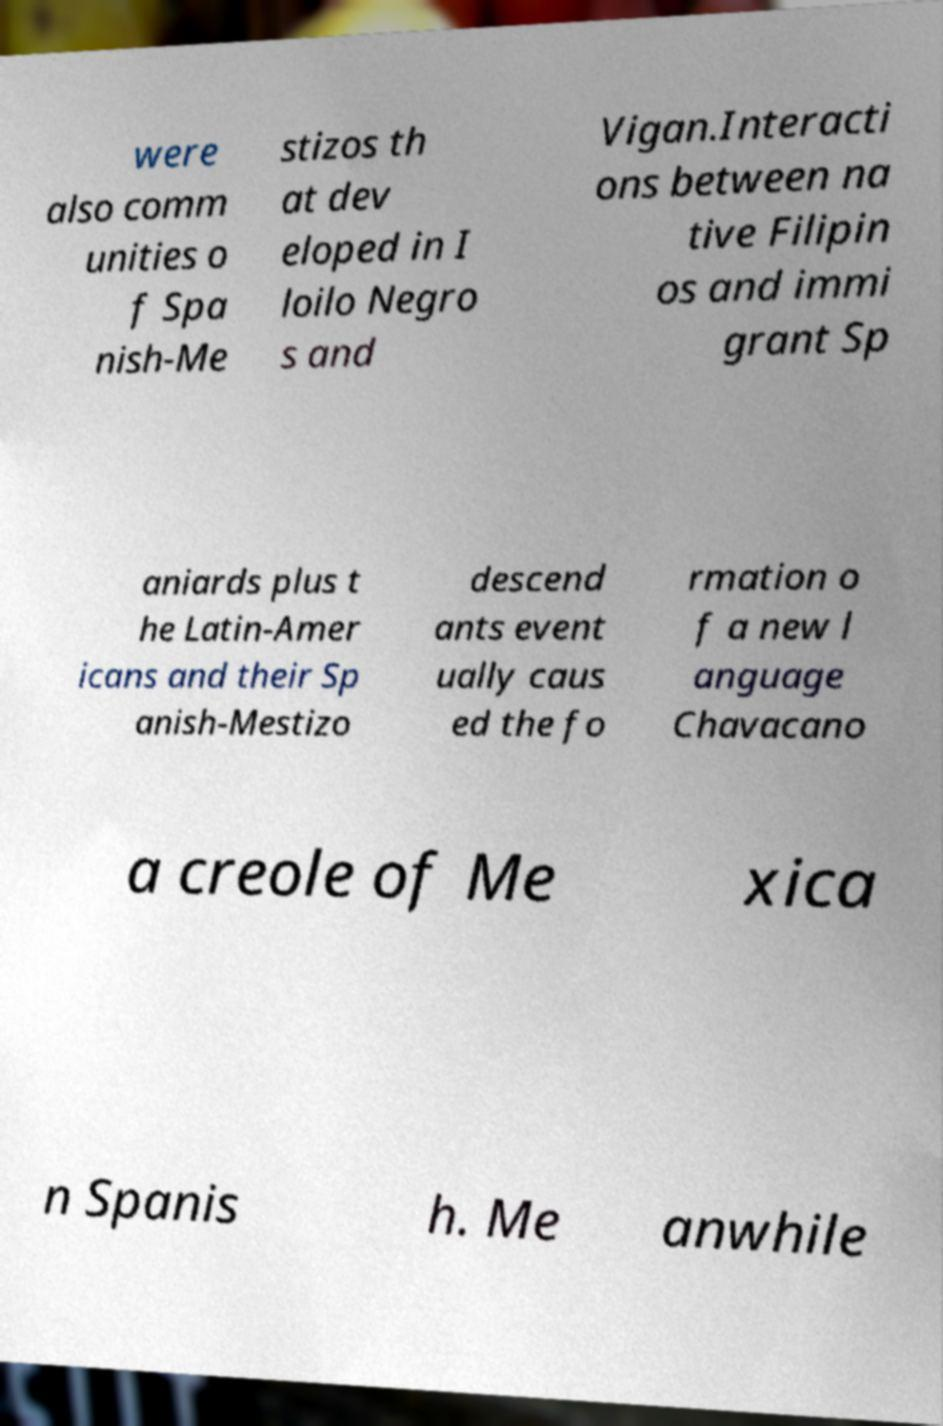Can you read and provide the text displayed in the image?This photo seems to have some interesting text. Can you extract and type it out for me? were also comm unities o f Spa nish-Me stizos th at dev eloped in I loilo Negro s and Vigan.Interacti ons between na tive Filipin os and immi grant Sp aniards plus t he Latin-Amer icans and their Sp anish-Mestizo descend ants event ually caus ed the fo rmation o f a new l anguage Chavacano a creole of Me xica n Spanis h. Me anwhile 